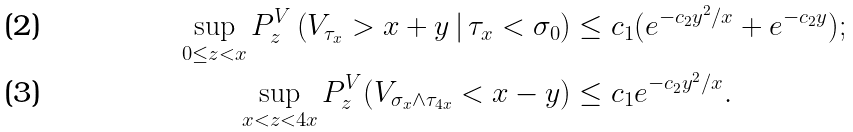Convert formula to latex. <formula><loc_0><loc_0><loc_500><loc_500>\sup _ { 0 \leq z < x } P _ { z } ^ { V } \left ( V _ { \tau _ { x } } > x + y \, | \, \tau _ { x } < \sigma _ { 0 } \right ) & \leq c _ { 1 } ( e ^ { - c _ { 2 } y ^ { 2 } / x } + e ^ { - c _ { 2 } y } ) ; \\ \sup _ { x < z < 4 x } P _ { z } ^ { V } ( V _ { \sigma _ { x } \wedge \tau _ { 4 x } } < x - y ) & \leq c _ { 1 } e ^ { - c _ { 2 } y ^ { 2 } / x } .</formula> 